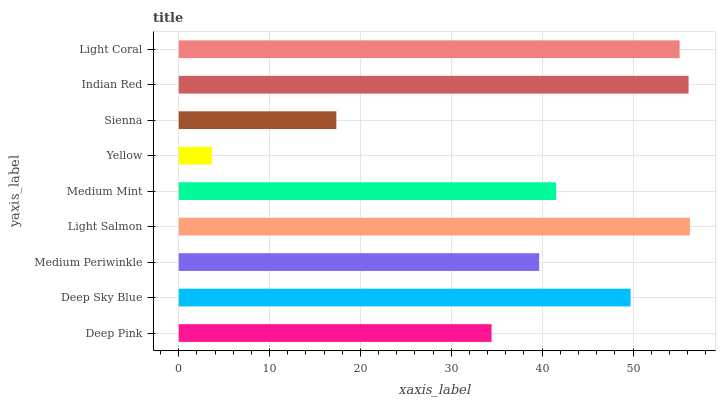Is Yellow the minimum?
Answer yes or no. Yes. Is Light Salmon the maximum?
Answer yes or no. Yes. Is Deep Sky Blue the minimum?
Answer yes or no. No. Is Deep Sky Blue the maximum?
Answer yes or no. No. Is Deep Sky Blue greater than Deep Pink?
Answer yes or no. Yes. Is Deep Pink less than Deep Sky Blue?
Answer yes or no. Yes. Is Deep Pink greater than Deep Sky Blue?
Answer yes or no. No. Is Deep Sky Blue less than Deep Pink?
Answer yes or no. No. Is Medium Mint the high median?
Answer yes or no. Yes. Is Medium Mint the low median?
Answer yes or no. Yes. Is Yellow the high median?
Answer yes or no. No. Is Light Salmon the low median?
Answer yes or no. No. 